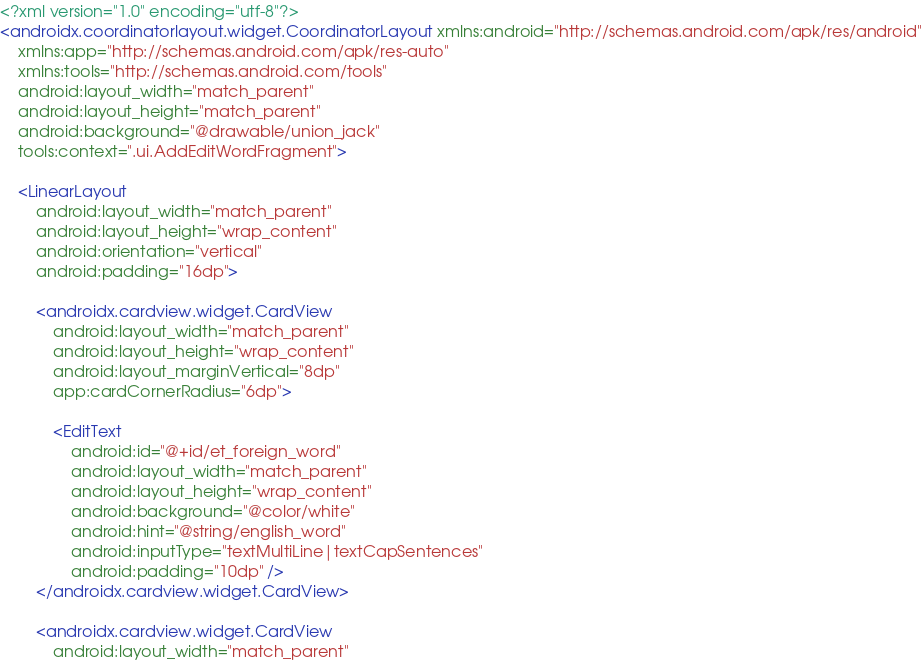<code> <loc_0><loc_0><loc_500><loc_500><_XML_><?xml version="1.0" encoding="utf-8"?>
<androidx.coordinatorlayout.widget.CoordinatorLayout xmlns:android="http://schemas.android.com/apk/res/android"
    xmlns:app="http://schemas.android.com/apk/res-auto"
    xmlns:tools="http://schemas.android.com/tools"
    android:layout_width="match_parent"
    android:layout_height="match_parent"
    android:background="@drawable/union_jack"
    tools:context=".ui.AddEditWordFragment">

    <LinearLayout
        android:layout_width="match_parent"
        android:layout_height="wrap_content"
        android:orientation="vertical"
        android:padding="16dp">

        <androidx.cardview.widget.CardView
            android:layout_width="match_parent"
            android:layout_height="wrap_content"
            android:layout_marginVertical="8dp"
            app:cardCornerRadius="6dp">

            <EditText
                android:id="@+id/et_foreign_word"
                android:layout_width="match_parent"
                android:layout_height="wrap_content"
                android:background="@color/white"
                android:hint="@string/english_word"
                android:inputType="textMultiLine|textCapSentences"
                android:padding="10dp" />
        </androidx.cardview.widget.CardView>

        <androidx.cardview.widget.CardView
            android:layout_width="match_parent"</code> 